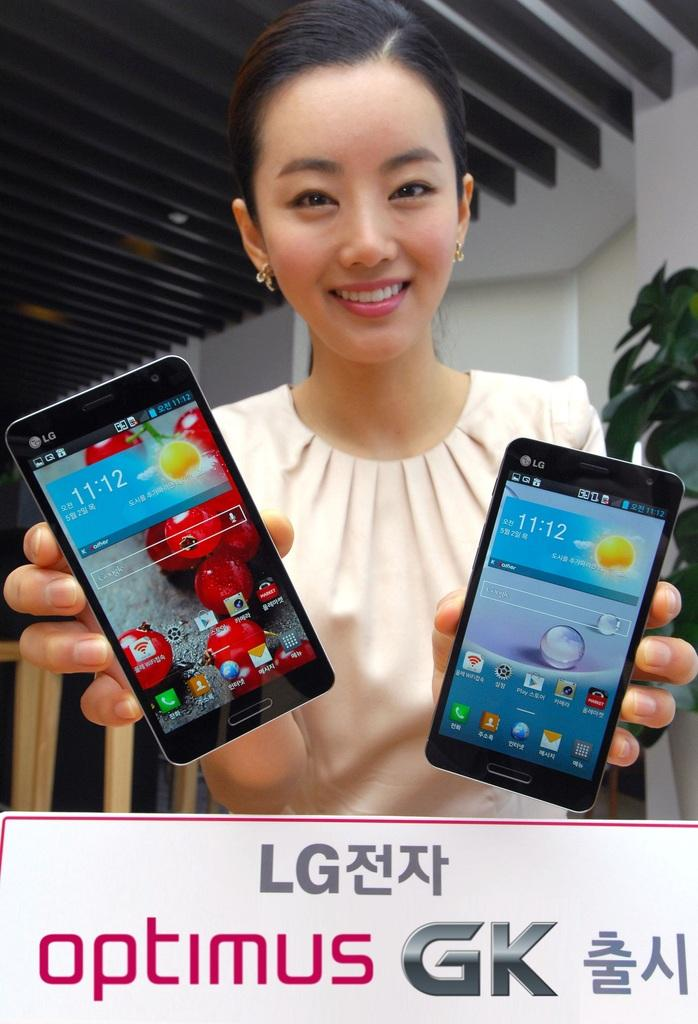<image>
Relay a brief, clear account of the picture shown. A smiling woman holds up two LG Optimus GK phones. 